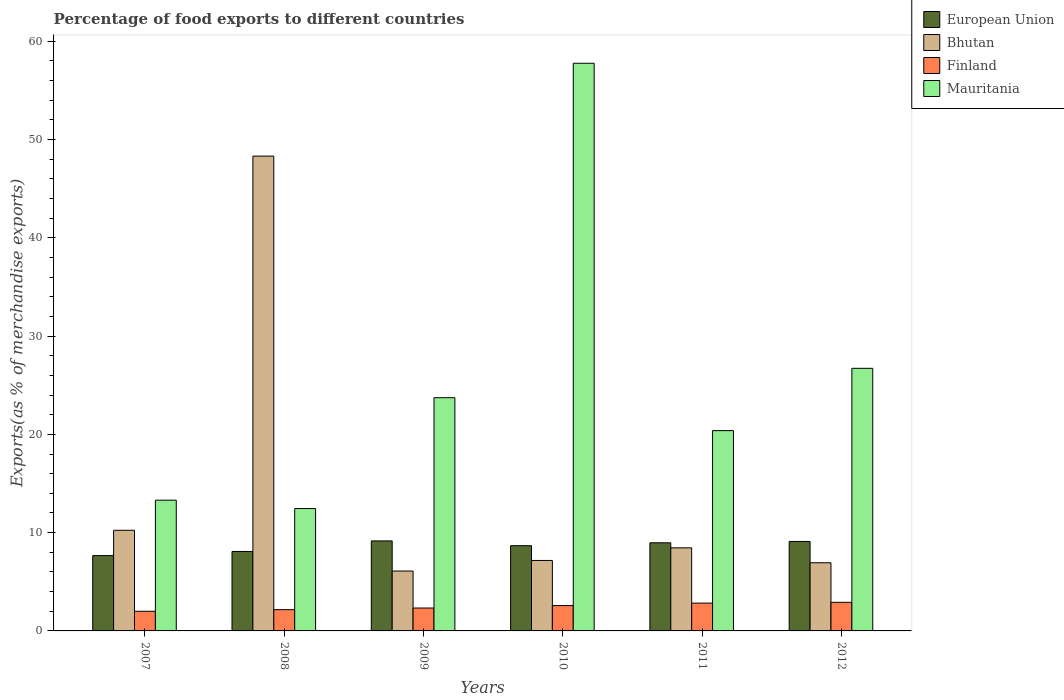How many groups of bars are there?
Provide a succinct answer. 6. Are the number of bars per tick equal to the number of legend labels?
Your answer should be compact. Yes. In how many cases, is the number of bars for a given year not equal to the number of legend labels?
Make the answer very short. 0. What is the percentage of exports to different countries in European Union in 2007?
Your answer should be very brief. 7.66. Across all years, what is the maximum percentage of exports to different countries in Finland?
Make the answer very short. 2.91. Across all years, what is the minimum percentage of exports to different countries in Finland?
Provide a succinct answer. 2. What is the total percentage of exports to different countries in Finland in the graph?
Give a very brief answer. 14.81. What is the difference between the percentage of exports to different countries in Mauritania in 2007 and that in 2010?
Make the answer very short. -44.46. What is the difference between the percentage of exports to different countries in Mauritania in 2007 and the percentage of exports to different countries in Bhutan in 2012?
Offer a terse response. 6.37. What is the average percentage of exports to different countries in Mauritania per year?
Keep it short and to the point. 25.73. In the year 2010, what is the difference between the percentage of exports to different countries in Finland and percentage of exports to different countries in Mauritania?
Give a very brief answer. -55.18. What is the ratio of the percentage of exports to different countries in Bhutan in 2007 to that in 2012?
Your answer should be very brief. 1.48. Is the difference between the percentage of exports to different countries in Finland in 2009 and 2010 greater than the difference between the percentage of exports to different countries in Mauritania in 2009 and 2010?
Provide a succinct answer. Yes. What is the difference between the highest and the second highest percentage of exports to different countries in Finland?
Provide a succinct answer. 0.08. What is the difference between the highest and the lowest percentage of exports to different countries in Bhutan?
Make the answer very short. 42.22. Is the sum of the percentage of exports to different countries in Mauritania in 2008 and 2011 greater than the maximum percentage of exports to different countries in Finland across all years?
Ensure brevity in your answer.  Yes. Is it the case that in every year, the sum of the percentage of exports to different countries in European Union and percentage of exports to different countries in Mauritania is greater than the sum of percentage of exports to different countries in Bhutan and percentage of exports to different countries in Finland?
Provide a succinct answer. No. What does the 2nd bar from the left in 2009 represents?
Provide a succinct answer. Bhutan. What does the 3rd bar from the right in 2009 represents?
Make the answer very short. Bhutan. How many bars are there?
Offer a very short reply. 24. What is the difference between two consecutive major ticks on the Y-axis?
Provide a succinct answer. 10. Does the graph contain any zero values?
Provide a succinct answer. No. Does the graph contain grids?
Your answer should be very brief. No. How many legend labels are there?
Make the answer very short. 4. What is the title of the graph?
Ensure brevity in your answer.  Percentage of food exports to different countries. Does "Faeroe Islands" appear as one of the legend labels in the graph?
Keep it short and to the point. No. What is the label or title of the Y-axis?
Provide a short and direct response. Exports(as % of merchandise exports). What is the Exports(as % of merchandise exports) of European Union in 2007?
Ensure brevity in your answer.  7.66. What is the Exports(as % of merchandise exports) of Bhutan in 2007?
Provide a succinct answer. 10.24. What is the Exports(as % of merchandise exports) of Finland in 2007?
Give a very brief answer. 2. What is the Exports(as % of merchandise exports) in Mauritania in 2007?
Provide a succinct answer. 13.3. What is the Exports(as % of merchandise exports) of European Union in 2008?
Give a very brief answer. 8.09. What is the Exports(as % of merchandise exports) in Bhutan in 2008?
Offer a very short reply. 48.32. What is the Exports(as % of merchandise exports) of Finland in 2008?
Offer a very short reply. 2.16. What is the Exports(as % of merchandise exports) of Mauritania in 2008?
Give a very brief answer. 12.45. What is the Exports(as % of merchandise exports) in European Union in 2009?
Give a very brief answer. 9.16. What is the Exports(as % of merchandise exports) in Bhutan in 2009?
Make the answer very short. 6.09. What is the Exports(as % of merchandise exports) of Finland in 2009?
Offer a very short reply. 2.33. What is the Exports(as % of merchandise exports) of Mauritania in 2009?
Ensure brevity in your answer.  23.73. What is the Exports(as % of merchandise exports) in European Union in 2010?
Provide a short and direct response. 8.67. What is the Exports(as % of merchandise exports) in Bhutan in 2010?
Keep it short and to the point. 7.17. What is the Exports(as % of merchandise exports) of Finland in 2010?
Keep it short and to the point. 2.58. What is the Exports(as % of merchandise exports) in Mauritania in 2010?
Keep it short and to the point. 57.76. What is the Exports(as % of merchandise exports) in European Union in 2011?
Keep it short and to the point. 8.97. What is the Exports(as % of merchandise exports) of Bhutan in 2011?
Ensure brevity in your answer.  8.45. What is the Exports(as % of merchandise exports) in Finland in 2011?
Provide a short and direct response. 2.83. What is the Exports(as % of merchandise exports) of Mauritania in 2011?
Your response must be concise. 20.38. What is the Exports(as % of merchandise exports) of European Union in 2012?
Give a very brief answer. 9.1. What is the Exports(as % of merchandise exports) in Bhutan in 2012?
Offer a terse response. 6.94. What is the Exports(as % of merchandise exports) in Finland in 2012?
Your answer should be compact. 2.91. What is the Exports(as % of merchandise exports) of Mauritania in 2012?
Offer a very short reply. 26.72. Across all years, what is the maximum Exports(as % of merchandise exports) in European Union?
Make the answer very short. 9.16. Across all years, what is the maximum Exports(as % of merchandise exports) in Bhutan?
Offer a terse response. 48.32. Across all years, what is the maximum Exports(as % of merchandise exports) of Finland?
Offer a very short reply. 2.91. Across all years, what is the maximum Exports(as % of merchandise exports) of Mauritania?
Your answer should be very brief. 57.76. Across all years, what is the minimum Exports(as % of merchandise exports) in European Union?
Your answer should be very brief. 7.66. Across all years, what is the minimum Exports(as % of merchandise exports) in Bhutan?
Ensure brevity in your answer.  6.09. Across all years, what is the minimum Exports(as % of merchandise exports) in Finland?
Offer a terse response. 2. Across all years, what is the minimum Exports(as % of merchandise exports) of Mauritania?
Your answer should be compact. 12.45. What is the total Exports(as % of merchandise exports) of European Union in the graph?
Your answer should be compact. 51.65. What is the total Exports(as % of merchandise exports) in Bhutan in the graph?
Offer a terse response. 87.21. What is the total Exports(as % of merchandise exports) in Finland in the graph?
Make the answer very short. 14.81. What is the total Exports(as % of merchandise exports) in Mauritania in the graph?
Your answer should be compact. 154.35. What is the difference between the Exports(as % of merchandise exports) of European Union in 2007 and that in 2008?
Ensure brevity in your answer.  -0.42. What is the difference between the Exports(as % of merchandise exports) in Bhutan in 2007 and that in 2008?
Your answer should be compact. -38.08. What is the difference between the Exports(as % of merchandise exports) of Finland in 2007 and that in 2008?
Ensure brevity in your answer.  -0.16. What is the difference between the Exports(as % of merchandise exports) of Mauritania in 2007 and that in 2008?
Your answer should be compact. 0.85. What is the difference between the Exports(as % of merchandise exports) of European Union in 2007 and that in 2009?
Give a very brief answer. -1.49. What is the difference between the Exports(as % of merchandise exports) in Bhutan in 2007 and that in 2009?
Your answer should be very brief. 4.14. What is the difference between the Exports(as % of merchandise exports) in Finland in 2007 and that in 2009?
Offer a very short reply. -0.33. What is the difference between the Exports(as % of merchandise exports) of Mauritania in 2007 and that in 2009?
Provide a short and direct response. -10.43. What is the difference between the Exports(as % of merchandise exports) of European Union in 2007 and that in 2010?
Make the answer very short. -1.01. What is the difference between the Exports(as % of merchandise exports) in Bhutan in 2007 and that in 2010?
Your answer should be compact. 3.07. What is the difference between the Exports(as % of merchandise exports) in Finland in 2007 and that in 2010?
Make the answer very short. -0.58. What is the difference between the Exports(as % of merchandise exports) in Mauritania in 2007 and that in 2010?
Give a very brief answer. -44.46. What is the difference between the Exports(as % of merchandise exports) of European Union in 2007 and that in 2011?
Ensure brevity in your answer.  -1.3. What is the difference between the Exports(as % of merchandise exports) in Bhutan in 2007 and that in 2011?
Provide a short and direct response. 1.79. What is the difference between the Exports(as % of merchandise exports) of Finland in 2007 and that in 2011?
Your answer should be compact. -0.83. What is the difference between the Exports(as % of merchandise exports) of Mauritania in 2007 and that in 2011?
Offer a very short reply. -7.08. What is the difference between the Exports(as % of merchandise exports) in European Union in 2007 and that in 2012?
Keep it short and to the point. -1.44. What is the difference between the Exports(as % of merchandise exports) of Bhutan in 2007 and that in 2012?
Provide a short and direct response. 3.3. What is the difference between the Exports(as % of merchandise exports) in Finland in 2007 and that in 2012?
Keep it short and to the point. -0.91. What is the difference between the Exports(as % of merchandise exports) of Mauritania in 2007 and that in 2012?
Give a very brief answer. -13.42. What is the difference between the Exports(as % of merchandise exports) in European Union in 2008 and that in 2009?
Make the answer very short. -1.07. What is the difference between the Exports(as % of merchandise exports) of Bhutan in 2008 and that in 2009?
Provide a succinct answer. 42.22. What is the difference between the Exports(as % of merchandise exports) in Finland in 2008 and that in 2009?
Ensure brevity in your answer.  -0.17. What is the difference between the Exports(as % of merchandise exports) of Mauritania in 2008 and that in 2009?
Your answer should be compact. -11.28. What is the difference between the Exports(as % of merchandise exports) in European Union in 2008 and that in 2010?
Provide a short and direct response. -0.59. What is the difference between the Exports(as % of merchandise exports) of Bhutan in 2008 and that in 2010?
Offer a terse response. 41.15. What is the difference between the Exports(as % of merchandise exports) in Finland in 2008 and that in 2010?
Keep it short and to the point. -0.42. What is the difference between the Exports(as % of merchandise exports) in Mauritania in 2008 and that in 2010?
Your answer should be very brief. -45.31. What is the difference between the Exports(as % of merchandise exports) of European Union in 2008 and that in 2011?
Offer a very short reply. -0.88. What is the difference between the Exports(as % of merchandise exports) of Bhutan in 2008 and that in 2011?
Ensure brevity in your answer.  39.86. What is the difference between the Exports(as % of merchandise exports) in Finland in 2008 and that in 2011?
Your response must be concise. -0.66. What is the difference between the Exports(as % of merchandise exports) of Mauritania in 2008 and that in 2011?
Your response must be concise. -7.93. What is the difference between the Exports(as % of merchandise exports) in European Union in 2008 and that in 2012?
Provide a succinct answer. -1.02. What is the difference between the Exports(as % of merchandise exports) in Bhutan in 2008 and that in 2012?
Offer a very short reply. 41.38. What is the difference between the Exports(as % of merchandise exports) in Finland in 2008 and that in 2012?
Offer a terse response. -0.75. What is the difference between the Exports(as % of merchandise exports) in Mauritania in 2008 and that in 2012?
Offer a terse response. -14.27. What is the difference between the Exports(as % of merchandise exports) of European Union in 2009 and that in 2010?
Your answer should be very brief. 0.49. What is the difference between the Exports(as % of merchandise exports) of Bhutan in 2009 and that in 2010?
Ensure brevity in your answer.  -1.08. What is the difference between the Exports(as % of merchandise exports) in Finland in 2009 and that in 2010?
Make the answer very short. -0.25. What is the difference between the Exports(as % of merchandise exports) of Mauritania in 2009 and that in 2010?
Keep it short and to the point. -34.03. What is the difference between the Exports(as % of merchandise exports) in European Union in 2009 and that in 2011?
Offer a terse response. 0.19. What is the difference between the Exports(as % of merchandise exports) in Bhutan in 2009 and that in 2011?
Offer a terse response. -2.36. What is the difference between the Exports(as % of merchandise exports) in Finland in 2009 and that in 2011?
Make the answer very short. -0.5. What is the difference between the Exports(as % of merchandise exports) in Mauritania in 2009 and that in 2011?
Provide a short and direct response. 3.35. What is the difference between the Exports(as % of merchandise exports) of European Union in 2009 and that in 2012?
Offer a terse response. 0.05. What is the difference between the Exports(as % of merchandise exports) of Bhutan in 2009 and that in 2012?
Provide a succinct answer. -0.84. What is the difference between the Exports(as % of merchandise exports) of Finland in 2009 and that in 2012?
Your answer should be very brief. -0.58. What is the difference between the Exports(as % of merchandise exports) in Mauritania in 2009 and that in 2012?
Keep it short and to the point. -2.99. What is the difference between the Exports(as % of merchandise exports) in European Union in 2010 and that in 2011?
Provide a succinct answer. -0.29. What is the difference between the Exports(as % of merchandise exports) of Bhutan in 2010 and that in 2011?
Give a very brief answer. -1.28. What is the difference between the Exports(as % of merchandise exports) in Finland in 2010 and that in 2011?
Provide a short and direct response. -0.25. What is the difference between the Exports(as % of merchandise exports) in Mauritania in 2010 and that in 2011?
Keep it short and to the point. 37.38. What is the difference between the Exports(as % of merchandise exports) in European Union in 2010 and that in 2012?
Provide a succinct answer. -0.43. What is the difference between the Exports(as % of merchandise exports) in Bhutan in 2010 and that in 2012?
Offer a very short reply. 0.23. What is the difference between the Exports(as % of merchandise exports) of Finland in 2010 and that in 2012?
Offer a very short reply. -0.33. What is the difference between the Exports(as % of merchandise exports) of Mauritania in 2010 and that in 2012?
Provide a short and direct response. 31.04. What is the difference between the Exports(as % of merchandise exports) of European Union in 2011 and that in 2012?
Your answer should be compact. -0.14. What is the difference between the Exports(as % of merchandise exports) in Bhutan in 2011 and that in 2012?
Your response must be concise. 1.52. What is the difference between the Exports(as % of merchandise exports) in Finland in 2011 and that in 2012?
Make the answer very short. -0.08. What is the difference between the Exports(as % of merchandise exports) of Mauritania in 2011 and that in 2012?
Ensure brevity in your answer.  -6.34. What is the difference between the Exports(as % of merchandise exports) of European Union in 2007 and the Exports(as % of merchandise exports) of Bhutan in 2008?
Your answer should be very brief. -40.65. What is the difference between the Exports(as % of merchandise exports) of European Union in 2007 and the Exports(as % of merchandise exports) of Finland in 2008?
Your response must be concise. 5.5. What is the difference between the Exports(as % of merchandise exports) of European Union in 2007 and the Exports(as % of merchandise exports) of Mauritania in 2008?
Provide a succinct answer. -4.79. What is the difference between the Exports(as % of merchandise exports) in Bhutan in 2007 and the Exports(as % of merchandise exports) in Finland in 2008?
Offer a very short reply. 8.08. What is the difference between the Exports(as % of merchandise exports) in Bhutan in 2007 and the Exports(as % of merchandise exports) in Mauritania in 2008?
Give a very brief answer. -2.21. What is the difference between the Exports(as % of merchandise exports) of Finland in 2007 and the Exports(as % of merchandise exports) of Mauritania in 2008?
Make the answer very short. -10.45. What is the difference between the Exports(as % of merchandise exports) in European Union in 2007 and the Exports(as % of merchandise exports) in Bhutan in 2009?
Provide a short and direct response. 1.57. What is the difference between the Exports(as % of merchandise exports) of European Union in 2007 and the Exports(as % of merchandise exports) of Finland in 2009?
Keep it short and to the point. 5.34. What is the difference between the Exports(as % of merchandise exports) in European Union in 2007 and the Exports(as % of merchandise exports) in Mauritania in 2009?
Offer a very short reply. -16.07. What is the difference between the Exports(as % of merchandise exports) in Bhutan in 2007 and the Exports(as % of merchandise exports) in Finland in 2009?
Provide a succinct answer. 7.91. What is the difference between the Exports(as % of merchandise exports) in Bhutan in 2007 and the Exports(as % of merchandise exports) in Mauritania in 2009?
Ensure brevity in your answer.  -13.49. What is the difference between the Exports(as % of merchandise exports) in Finland in 2007 and the Exports(as % of merchandise exports) in Mauritania in 2009?
Your answer should be compact. -21.73. What is the difference between the Exports(as % of merchandise exports) in European Union in 2007 and the Exports(as % of merchandise exports) in Bhutan in 2010?
Provide a succinct answer. 0.49. What is the difference between the Exports(as % of merchandise exports) in European Union in 2007 and the Exports(as % of merchandise exports) in Finland in 2010?
Make the answer very short. 5.08. What is the difference between the Exports(as % of merchandise exports) of European Union in 2007 and the Exports(as % of merchandise exports) of Mauritania in 2010?
Ensure brevity in your answer.  -50.1. What is the difference between the Exports(as % of merchandise exports) of Bhutan in 2007 and the Exports(as % of merchandise exports) of Finland in 2010?
Provide a succinct answer. 7.66. What is the difference between the Exports(as % of merchandise exports) in Bhutan in 2007 and the Exports(as % of merchandise exports) in Mauritania in 2010?
Offer a terse response. -47.52. What is the difference between the Exports(as % of merchandise exports) of Finland in 2007 and the Exports(as % of merchandise exports) of Mauritania in 2010?
Provide a succinct answer. -55.76. What is the difference between the Exports(as % of merchandise exports) of European Union in 2007 and the Exports(as % of merchandise exports) of Bhutan in 2011?
Provide a short and direct response. -0.79. What is the difference between the Exports(as % of merchandise exports) in European Union in 2007 and the Exports(as % of merchandise exports) in Finland in 2011?
Make the answer very short. 4.84. What is the difference between the Exports(as % of merchandise exports) of European Union in 2007 and the Exports(as % of merchandise exports) of Mauritania in 2011?
Your answer should be very brief. -12.72. What is the difference between the Exports(as % of merchandise exports) of Bhutan in 2007 and the Exports(as % of merchandise exports) of Finland in 2011?
Keep it short and to the point. 7.41. What is the difference between the Exports(as % of merchandise exports) of Bhutan in 2007 and the Exports(as % of merchandise exports) of Mauritania in 2011?
Make the answer very short. -10.14. What is the difference between the Exports(as % of merchandise exports) in Finland in 2007 and the Exports(as % of merchandise exports) in Mauritania in 2011?
Offer a very short reply. -18.38. What is the difference between the Exports(as % of merchandise exports) in European Union in 2007 and the Exports(as % of merchandise exports) in Bhutan in 2012?
Provide a succinct answer. 0.73. What is the difference between the Exports(as % of merchandise exports) of European Union in 2007 and the Exports(as % of merchandise exports) of Finland in 2012?
Ensure brevity in your answer.  4.76. What is the difference between the Exports(as % of merchandise exports) in European Union in 2007 and the Exports(as % of merchandise exports) in Mauritania in 2012?
Offer a terse response. -19.06. What is the difference between the Exports(as % of merchandise exports) of Bhutan in 2007 and the Exports(as % of merchandise exports) of Finland in 2012?
Keep it short and to the point. 7.33. What is the difference between the Exports(as % of merchandise exports) of Bhutan in 2007 and the Exports(as % of merchandise exports) of Mauritania in 2012?
Offer a very short reply. -16.48. What is the difference between the Exports(as % of merchandise exports) in Finland in 2007 and the Exports(as % of merchandise exports) in Mauritania in 2012?
Provide a short and direct response. -24.72. What is the difference between the Exports(as % of merchandise exports) of European Union in 2008 and the Exports(as % of merchandise exports) of Bhutan in 2009?
Make the answer very short. 1.99. What is the difference between the Exports(as % of merchandise exports) of European Union in 2008 and the Exports(as % of merchandise exports) of Finland in 2009?
Your answer should be compact. 5.76. What is the difference between the Exports(as % of merchandise exports) in European Union in 2008 and the Exports(as % of merchandise exports) in Mauritania in 2009?
Keep it short and to the point. -15.65. What is the difference between the Exports(as % of merchandise exports) of Bhutan in 2008 and the Exports(as % of merchandise exports) of Finland in 2009?
Your response must be concise. 45.99. What is the difference between the Exports(as % of merchandise exports) in Bhutan in 2008 and the Exports(as % of merchandise exports) in Mauritania in 2009?
Your answer should be compact. 24.58. What is the difference between the Exports(as % of merchandise exports) in Finland in 2008 and the Exports(as % of merchandise exports) in Mauritania in 2009?
Keep it short and to the point. -21.57. What is the difference between the Exports(as % of merchandise exports) of European Union in 2008 and the Exports(as % of merchandise exports) of Bhutan in 2010?
Give a very brief answer. 0.92. What is the difference between the Exports(as % of merchandise exports) of European Union in 2008 and the Exports(as % of merchandise exports) of Finland in 2010?
Offer a terse response. 5.5. What is the difference between the Exports(as % of merchandise exports) in European Union in 2008 and the Exports(as % of merchandise exports) in Mauritania in 2010?
Your response must be concise. -49.68. What is the difference between the Exports(as % of merchandise exports) in Bhutan in 2008 and the Exports(as % of merchandise exports) in Finland in 2010?
Provide a succinct answer. 45.73. What is the difference between the Exports(as % of merchandise exports) of Bhutan in 2008 and the Exports(as % of merchandise exports) of Mauritania in 2010?
Offer a terse response. -9.45. What is the difference between the Exports(as % of merchandise exports) of Finland in 2008 and the Exports(as % of merchandise exports) of Mauritania in 2010?
Keep it short and to the point. -55.6. What is the difference between the Exports(as % of merchandise exports) of European Union in 2008 and the Exports(as % of merchandise exports) of Bhutan in 2011?
Provide a short and direct response. -0.37. What is the difference between the Exports(as % of merchandise exports) in European Union in 2008 and the Exports(as % of merchandise exports) in Finland in 2011?
Provide a short and direct response. 5.26. What is the difference between the Exports(as % of merchandise exports) of European Union in 2008 and the Exports(as % of merchandise exports) of Mauritania in 2011?
Give a very brief answer. -12.3. What is the difference between the Exports(as % of merchandise exports) in Bhutan in 2008 and the Exports(as % of merchandise exports) in Finland in 2011?
Provide a short and direct response. 45.49. What is the difference between the Exports(as % of merchandise exports) of Bhutan in 2008 and the Exports(as % of merchandise exports) of Mauritania in 2011?
Your answer should be compact. 27.93. What is the difference between the Exports(as % of merchandise exports) of Finland in 2008 and the Exports(as % of merchandise exports) of Mauritania in 2011?
Give a very brief answer. -18.22. What is the difference between the Exports(as % of merchandise exports) in European Union in 2008 and the Exports(as % of merchandise exports) in Bhutan in 2012?
Your response must be concise. 1.15. What is the difference between the Exports(as % of merchandise exports) of European Union in 2008 and the Exports(as % of merchandise exports) of Finland in 2012?
Offer a terse response. 5.18. What is the difference between the Exports(as % of merchandise exports) of European Union in 2008 and the Exports(as % of merchandise exports) of Mauritania in 2012?
Offer a terse response. -18.64. What is the difference between the Exports(as % of merchandise exports) in Bhutan in 2008 and the Exports(as % of merchandise exports) in Finland in 2012?
Your answer should be compact. 45.41. What is the difference between the Exports(as % of merchandise exports) in Bhutan in 2008 and the Exports(as % of merchandise exports) in Mauritania in 2012?
Your response must be concise. 21.59. What is the difference between the Exports(as % of merchandise exports) in Finland in 2008 and the Exports(as % of merchandise exports) in Mauritania in 2012?
Give a very brief answer. -24.56. What is the difference between the Exports(as % of merchandise exports) in European Union in 2009 and the Exports(as % of merchandise exports) in Bhutan in 2010?
Give a very brief answer. 1.99. What is the difference between the Exports(as % of merchandise exports) in European Union in 2009 and the Exports(as % of merchandise exports) in Finland in 2010?
Your answer should be very brief. 6.58. What is the difference between the Exports(as % of merchandise exports) in European Union in 2009 and the Exports(as % of merchandise exports) in Mauritania in 2010?
Offer a terse response. -48.6. What is the difference between the Exports(as % of merchandise exports) in Bhutan in 2009 and the Exports(as % of merchandise exports) in Finland in 2010?
Make the answer very short. 3.51. What is the difference between the Exports(as % of merchandise exports) in Bhutan in 2009 and the Exports(as % of merchandise exports) in Mauritania in 2010?
Offer a terse response. -51.67. What is the difference between the Exports(as % of merchandise exports) of Finland in 2009 and the Exports(as % of merchandise exports) of Mauritania in 2010?
Make the answer very short. -55.43. What is the difference between the Exports(as % of merchandise exports) in European Union in 2009 and the Exports(as % of merchandise exports) in Bhutan in 2011?
Keep it short and to the point. 0.71. What is the difference between the Exports(as % of merchandise exports) in European Union in 2009 and the Exports(as % of merchandise exports) in Finland in 2011?
Keep it short and to the point. 6.33. What is the difference between the Exports(as % of merchandise exports) in European Union in 2009 and the Exports(as % of merchandise exports) in Mauritania in 2011?
Keep it short and to the point. -11.22. What is the difference between the Exports(as % of merchandise exports) of Bhutan in 2009 and the Exports(as % of merchandise exports) of Finland in 2011?
Give a very brief answer. 3.27. What is the difference between the Exports(as % of merchandise exports) in Bhutan in 2009 and the Exports(as % of merchandise exports) in Mauritania in 2011?
Offer a very short reply. -14.29. What is the difference between the Exports(as % of merchandise exports) of Finland in 2009 and the Exports(as % of merchandise exports) of Mauritania in 2011?
Provide a succinct answer. -18.05. What is the difference between the Exports(as % of merchandise exports) of European Union in 2009 and the Exports(as % of merchandise exports) of Bhutan in 2012?
Your answer should be compact. 2.22. What is the difference between the Exports(as % of merchandise exports) in European Union in 2009 and the Exports(as % of merchandise exports) in Finland in 2012?
Provide a short and direct response. 6.25. What is the difference between the Exports(as % of merchandise exports) of European Union in 2009 and the Exports(as % of merchandise exports) of Mauritania in 2012?
Make the answer very short. -17.56. What is the difference between the Exports(as % of merchandise exports) in Bhutan in 2009 and the Exports(as % of merchandise exports) in Finland in 2012?
Ensure brevity in your answer.  3.19. What is the difference between the Exports(as % of merchandise exports) in Bhutan in 2009 and the Exports(as % of merchandise exports) in Mauritania in 2012?
Offer a terse response. -20.63. What is the difference between the Exports(as % of merchandise exports) in Finland in 2009 and the Exports(as % of merchandise exports) in Mauritania in 2012?
Make the answer very short. -24.39. What is the difference between the Exports(as % of merchandise exports) in European Union in 2010 and the Exports(as % of merchandise exports) in Bhutan in 2011?
Provide a succinct answer. 0.22. What is the difference between the Exports(as % of merchandise exports) of European Union in 2010 and the Exports(as % of merchandise exports) of Finland in 2011?
Ensure brevity in your answer.  5.85. What is the difference between the Exports(as % of merchandise exports) in European Union in 2010 and the Exports(as % of merchandise exports) in Mauritania in 2011?
Your answer should be very brief. -11.71. What is the difference between the Exports(as % of merchandise exports) of Bhutan in 2010 and the Exports(as % of merchandise exports) of Finland in 2011?
Provide a short and direct response. 4.34. What is the difference between the Exports(as % of merchandise exports) in Bhutan in 2010 and the Exports(as % of merchandise exports) in Mauritania in 2011?
Provide a succinct answer. -13.21. What is the difference between the Exports(as % of merchandise exports) of Finland in 2010 and the Exports(as % of merchandise exports) of Mauritania in 2011?
Offer a terse response. -17.8. What is the difference between the Exports(as % of merchandise exports) of European Union in 2010 and the Exports(as % of merchandise exports) of Bhutan in 2012?
Make the answer very short. 1.74. What is the difference between the Exports(as % of merchandise exports) of European Union in 2010 and the Exports(as % of merchandise exports) of Finland in 2012?
Your response must be concise. 5.76. What is the difference between the Exports(as % of merchandise exports) of European Union in 2010 and the Exports(as % of merchandise exports) of Mauritania in 2012?
Keep it short and to the point. -18.05. What is the difference between the Exports(as % of merchandise exports) in Bhutan in 2010 and the Exports(as % of merchandise exports) in Finland in 2012?
Give a very brief answer. 4.26. What is the difference between the Exports(as % of merchandise exports) in Bhutan in 2010 and the Exports(as % of merchandise exports) in Mauritania in 2012?
Your response must be concise. -19.55. What is the difference between the Exports(as % of merchandise exports) in Finland in 2010 and the Exports(as % of merchandise exports) in Mauritania in 2012?
Offer a very short reply. -24.14. What is the difference between the Exports(as % of merchandise exports) in European Union in 2011 and the Exports(as % of merchandise exports) in Bhutan in 2012?
Your answer should be very brief. 2.03. What is the difference between the Exports(as % of merchandise exports) in European Union in 2011 and the Exports(as % of merchandise exports) in Finland in 2012?
Your response must be concise. 6.06. What is the difference between the Exports(as % of merchandise exports) of European Union in 2011 and the Exports(as % of merchandise exports) of Mauritania in 2012?
Offer a terse response. -17.75. What is the difference between the Exports(as % of merchandise exports) of Bhutan in 2011 and the Exports(as % of merchandise exports) of Finland in 2012?
Give a very brief answer. 5.54. What is the difference between the Exports(as % of merchandise exports) of Bhutan in 2011 and the Exports(as % of merchandise exports) of Mauritania in 2012?
Your answer should be compact. -18.27. What is the difference between the Exports(as % of merchandise exports) of Finland in 2011 and the Exports(as % of merchandise exports) of Mauritania in 2012?
Make the answer very short. -23.89. What is the average Exports(as % of merchandise exports) in European Union per year?
Your response must be concise. 8.61. What is the average Exports(as % of merchandise exports) in Bhutan per year?
Provide a succinct answer. 14.53. What is the average Exports(as % of merchandise exports) in Finland per year?
Your answer should be very brief. 2.47. What is the average Exports(as % of merchandise exports) of Mauritania per year?
Your answer should be compact. 25.73. In the year 2007, what is the difference between the Exports(as % of merchandise exports) in European Union and Exports(as % of merchandise exports) in Bhutan?
Your answer should be compact. -2.57. In the year 2007, what is the difference between the Exports(as % of merchandise exports) in European Union and Exports(as % of merchandise exports) in Finland?
Your answer should be very brief. 5.67. In the year 2007, what is the difference between the Exports(as % of merchandise exports) of European Union and Exports(as % of merchandise exports) of Mauritania?
Offer a terse response. -5.64. In the year 2007, what is the difference between the Exports(as % of merchandise exports) of Bhutan and Exports(as % of merchandise exports) of Finland?
Ensure brevity in your answer.  8.24. In the year 2007, what is the difference between the Exports(as % of merchandise exports) of Bhutan and Exports(as % of merchandise exports) of Mauritania?
Give a very brief answer. -3.06. In the year 2007, what is the difference between the Exports(as % of merchandise exports) in Finland and Exports(as % of merchandise exports) in Mauritania?
Give a very brief answer. -11.3. In the year 2008, what is the difference between the Exports(as % of merchandise exports) of European Union and Exports(as % of merchandise exports) of Bhutan?
Offer a terse response. -40.23. In the year 2008, what is the difference between the Exports(as % of merchandise exports) in European Union and Exports(as % of merchandise exports) in Finland?
Your answer should be very brief. 5.92. In the year 2008, what is the difference between the Exports(as % of merchandise exports) in European Union and Exports(as % of merchandise exports) in Mauritania?
Your response must be concise. -4.37. In the year 2008, what is the difference between the Exports(as % of merchandise exports) of Bhutan and Exports(as % of merchandise exports) of Finland?
Your response must be concise. 46.15. In the year 2008, what is the difference between the Exports(as % of merchandise exports) in Bhutan and Exports(as % of merchandise exports) in Mauritania?
Your answer should be very brief. 35.86. In the year 2008, what is the difference between the Exports(as % of merchandise exports) of Finland and Exports(as % of merchandise exports) of Mauritania?
Provide a short and direct response. -10.29. In the year 2009, what is the difference between the Exports(as % of merchandise exports) in European Union and Exports(as % of merchandise exports) in Bhutan?
Give a very brief answer. 3.06. In the year 2009, what is the difference between the Exports(as % of merchandise exports) of European Union and Exports(as % of merchandise exports) of Finland?
Your answer should be very brief. 6.83. In the year 2009, what is the difference between the Exports(as % of merchandise exports) of European Union and Exports(as % of merchandise exports) of Mauritania?
Provide a succinct answer. -14.57. In the year 2009, what is the difference between the Exports(as % of merchandise exports) of Bhutan and Exports(as % of merchandise exports) of Finland?
Your response must be concise. 3.77. In the year 2009, what is the difference between the Exports(as % of merchandise exports) of Bhutan and Exports(as % of merchandise exports) of Mauritania?
Ensure brevity in your answer.  -17.64. In the year 2009, what is the difference between the Exports(as % of merchandise exports) in Finland and Exports(as % of merchandise exports) in Mauritania?
Ensure brevity in your answer.  -21.4. In the year 2010, what is the difference between the Exports(as % of merchandise exports) in European Union and Exports(as % of merchandise exports) in Bhutan?
Your answer should be compact. 1.5. In the year 2010, what is the difference between the Exports(as % of merchandise exports) in European Union and Exports(as % of merchandise exports) in Finland?
Your response must be concise. 6.09. In the year 2010, what is the difference between the Exports(as % of merchandise exports) of European Union and Exports(as % of merchandise exports) of Mauritania?
Ensure brevity in your answer.  -49.09. In the year 2010, what is the difference between the Exports(as % of merchandise exports) in Bhutan and Exports(as % of merchandise exports) in Finland?
Ensure brevity in your answer.  4.59. In the year 2010, what is the difference between the Exports(as % of merchandise exports) in Bhutan and Exports(as % of merchandise exports) in Mauritania?
Give a very brief answer. -50.59. In the year 2010, what is the difference between the Exports(as % of merchandise exports) in Finland and Exports(as % of merchandise exports) in Mauritania?
Provide a succinct answer. -55.18. In the year 2011, what is the difference between the Exports(as % of merchandise exports) of European Union and Exports(as % of merchandise exports) of Bhutan?
Your response must be concise. 0.51. In the year 2011, what is the difference between the Exports(as % of merchandise exports) of European Union and Exports(as % of merchandise exports) of Finland?
Ensure brevity in your answer.  6.14. In the year 2011, what is the difference between the Exports(as % of merchandise exports) in European Union and Exports(as % of merchandise exports) in Mauritania?
Give a very brief answer. -11.41. In the year 2011, what is the difference between the Exports(as % of merchandise exports) of Bhutan and Exports(as % of merchandise exports) of Finland?
Give a very brief answer. 5.63. In the year 2011, what is the difference between the Exports(as % of merchandise exports) in Bhutan and Exports(as % of merchandise exports) in Mauritania?
Provide a short and direct response. -11.93. In the year 2011, what is the difference between the Exports(as % of merchandise exports) in Finland and Exports(as % of merchandise exports) in Mauritania?
Ensure brevity in your answer.  -17.55. In the year 2012, what is the difference between the Exports(as % of merchandise exports) of European Union and Exports(as % of merchandise exports) of Bhutan?
Keep it short and to the point. 2.17. In the year 2012, what is the difference between the Exports(as % of merchandise exports) of European Union and Exports(as % of merchandise exports) of Finland?
Ensure brevity in your answer.  6.19. In the year 2012, what is the difference between the Exports(as % of merchandise exports) of European Union and Exports(as % of merchandise exports) of Mauritania?
Provide a succinct answer. -17.62. In the year 2012, what is the difference between the Exports(as % of merchandise exports) in Bhutan and Exports(as % of merchandise exports) in Finland?
Provide a succinct answer. 4.03. In the year 2012, what is the difference between the Exports(as % of merchandise exports) in Bhutan and Exports(as % of merchandise exports) in Mauritania?
Ensure brevity in your answer.  -19.78. In the year 2012, what is the difference between the Exports(as % of merchandise exports) in Finland and Exports(as % of merchandise exports) in Mauritania?
Give a very brief answer. -23.81. What is the ratio of the Exports(as % of merchandise exports) in European Union in 2007 to that in 2008?
Your response must be concise. 0.95. What is the ratio of the Exports(as % of merchandise exports) of Bhutan in 2007 to that in 2008?
Provide a succinct answer. 0.21. What is the ratio of the Exports(as % of merchandise exports) of Finland in 2007 to that in 2008?
Keep it short and to the point. 0.92. What is the ratio of the Exports(as % of merchandise exports) in Mauritania in 2007 to that in 2008?
Provide a succinct answer. 1.07. What is the ratio of the Exports(as % of merchandise exports) in European Union in 2007 to that in 2009?
Your answer should be very brief. 0.84. What is the ratio of the Exports(as % of merchandise exports) in Bhutan in 2007 to that in 2009?
Provide a succinct answer. 1.68. What is the ratio of the Exports(as % of merchandise exports) of Finland in 2007 to that in 2009?
Your answer should be compact. 0.86. What is the ratio of the Exports(as % of merchandise exports) of Mauritania in 2007 to that in 2009?
Ensure brevity in your answer.  0.56. What is the ratio of the Exports(as % of merchandise exports) in European Union in 2007 to that in 2010?
Give a very brief answer. 0.88. What is the ratio of the Exports(as % of merchandise exports) in Bhutan in 2007 to that in 2010?
Ensure brevity in your answer.  1.43. What is the ratio of the Exports(as % of merchandise exports) of Finland in 2007 to that in 2010?
Your answer should be compact. 0.77. What is the ratio of the Exports(as % of merchandise exports) in Mauritania in 2007 to that in 2010?
Offer a very short reply. 0.23. What is the ratio of the Exports(as % of merchandise exports) in European Union in 2007 to that in 2011?
Provide a short and direct response. 0.85. What is the ratio of the Exports(as % of merchandise exports) in Bhutan in 2007 to that in 2011?
Offer a very short reply. 1.21. What is the ratio of the Exports(as % of merchandise exports) of Finland in 2007 to that in 2011?
Give a very brief answer. 0.71. What is the ratio of the Exports(as % of merchandise exports) of Mauritania in 2007 to that in 2011?
Your answer should be compact. 0.65. What is the ratio of the Exports(as % of merchandise exports) in European Union in 2007 to that in 2012?
Provide a short and direct response. 0.84. What is the ratio of the Exports(as % of merchandise exports) of Bhutan in 2007 to that in 2012?
Your answer should be compact. 1.48. What is the ratio of the Exports(as % of merchandise exports) in Finland in 2007 to that in 2012?
Give a very brief answer. 0.69. What is the ratio of the Exports(as % of merchandise exports) of Mauritania in 2007 to that in 2012?
Provide a succinct answer. 0.5. What is the ratio of the Exports(as % of merchandise exports) of European Union in 2008 to that in 2009?
Provide a short and direct response. 0.88. What is the ratio of the Exports(as % of merchandise exports) in Bhutan in 2008 to that in 2009?
Offer a terse response. 7.93. What is the ratio of the Exports(as % of merchandise exports) of Finland in 2008 to that in 2009?
Your answer should be compact. 0.93. What is the ratio of the Exports(as % of merchandise exports) of Mauritania in 2008 to that in 2009?
Your answer should be very brief. 0.52. What is the ratio of the Exports(as % of merchandise exports) of European Union in 2008 to that in 2010?
Provide a short and direct response. 0.93. What is the ratio of the Exports(as % of merchandise exports) of Bhutan in 2008 to that in 2010?
Ensure brevity in your answer.  6.74. What is the ratio of the Exports(as % of merchandise exports) of Finland in 2008 to that in 2010?
Offer a very short reply. 0.84. What is the ratio of the Exports(as % of merchandise exports) in Mauritania in 2008 to that in 2010?
Offer a very short reply. 0.22. What is the ratio of the Exports(as % of merchandise exports) of European Union in 2008 to that in 2011?
Offer a terse response. 0.9. What is the ratio of the Exports(as % of merchandise exports) in Bhutan in 2008 to that in 2011?
Provide a succinct answer. 5.72. What is the ratio of the Exports(as % of merchandise exports) of Finland in 2008 to that in 2011?
Provide a succinct answer. 0.77. What is the ratio of the Exports(as % of merchandise exports) in Mauritania in 2008 to that in 2011?
Your answer should be compact. 0.61. What is the ratio of the Exports(as % of merchandise exports) of European Union in 2008 to that in 2012?
Your answer should be very brief. 0.89. What is the ratio of the Exports(as % of merchandise exports) in Bhutan in 2008 to that in 2012?
Keep it short and to the point. 6.97. What is the ratio of the Exports(as % of merchandise exports) in Finland in 2008 to that in 2012?
Offer a terse response. 0.74. What is the ratio of the Exports(as % of merchandise exports) of Mauritania in 2008 to that in 2012?
Make the answer very short. 0.47. What is the ratio of the Exports(as % of merchandise exports) in European Union in 2009 to that in 2010?
Offer a very short reply. 1.06. What is the ratio of the Exports(as % of merchandise exports) in Bhutan in 2009 to that in 2010?
Ensure brevity in your answer.  0.85. What is the ratio of the Exports(as % of merchandise exports) of Finland in 2009 to that in 2010?
Offer a terse response. 0.9. What is the ratio of the Exports(as % of merchandise exports) in Mauritania in 2009 to that in 2010?
Ensure brevity in your answer.  0.41. What is the ratio of the Exports(as % of merchandise exports) in European Union in 2009 to that in 2011?
Keep it short and to the point. 1.02. What is the ratio of the Exports(as % of merchandise exports) in Bhutan in 2009 to that in 2011?
Your answer should be compact. 0.72. What is the ratio of the Exports(as % of merchandise exports) of Finland in 2009 to that in 2011?
Give a very brief answer. 0.82. What is the ratio of the Exports(as % of merchandise exports) of Mauritania in 2009 to that in 2011?
Your response must be concise. 1.16. What is the ratio of the Exports(as % of merchandise exports) of Bhutan in 2009 to that in 2012?
Your response must be concise. 0.88. What is the ratio of the Exports(as % of merchandise exports) in Finland in 2009 to that in 2012?
Keep it short and to the point. 0.8. What is the ratio of the Exports(as % of merchandise exports) in Mauritania in 2009 to that in 2012?
Offer a terse response. 0.89. What is the ratio of the Exports(as % of merchandise exports) of European Union in 2010 to that in 2011?
Offer a terse response. 0.97. What is the ratio of the Exports(as % of merchandise exports) of Bhutan in 2010 to that in 2011?
Ensure brevity in your answer.  0.85. What is the ratio of the Exports(as % of merchandise exports) of Finland in 2010 to that in 2011?
Ensure brevity in your answer.  0.91. What is the ratio of the Exports(as % of merchandise exports) of Mauritania in 2010 to that in 2011?
Your response must be concise. 2.83. What is the ratio of the Exports(as % of merchandise exports) of European Union in 2010 to that in 2012?
Keep it short and to the point. 0.95. What is the ratio of the Exports(as % of merchandise exports) of Bhutan in 2010 to that in 2012?
Ensure brevity in your answer.  1.03. What is the ratio of the Exports(as % of merchandise exports) of Finland in 2010 to that in 2012?
Make the answer very short. 0.89. What is the ratio of the Exports(as % of merchandise exports) in Mauritania in 2010 to that in 2012?
Your response must be concise. 2.16. What is the ratio of the Exports(as % of merchandise exports) of Bhutan in 2011 to that in 2012?
Your response must be concise. 1.22. What is the ratio of the Exports(as % of merchandise exports) of Finland in 2011 to that in 2012?
Offer a very short reply. 0.97. What is the ratio of the Exports(as % of merchandise exports) of Mauritania in 2011 to that in 2012?
Ensure brevity in your answer.  0.76. What is the difference between the highest and the second highest Exports(as % of merchandise exports) of European Union?
Your response must be concise. 0.05. What is the difference between the highest and the second highest Exports(as % of merchandise exports) in Bhutan?
Your answer should be very brief. 38.08. What is the difference between the highest and the second highest Exports(as % of merchandise exports) in Finland?
Keep it short and to the point. 0.08. What is the difference between the highest and the second highest Exports(as % of merchandise exports) of Mauritania?
Your answer should be very brief. 31.04. What is the difference between the highest and the lowest Exports(as % of merchandise exports) in European Union?
Your answer should be compact. 1.49. What is the difference between the highest and the lowest Exports(as % of merchandise exports) in Bhutan?
Keep it short and to the point. 42.22. What is the difference between the highest and the lowest Exports(as % of merchandise exports) in Finland?
Make the answer very short. 0.91. What is the difference between the highest and the lowest Exports(as % of merchandise exports) of Mauritania?
Keep it short and to the point. 45.31. 